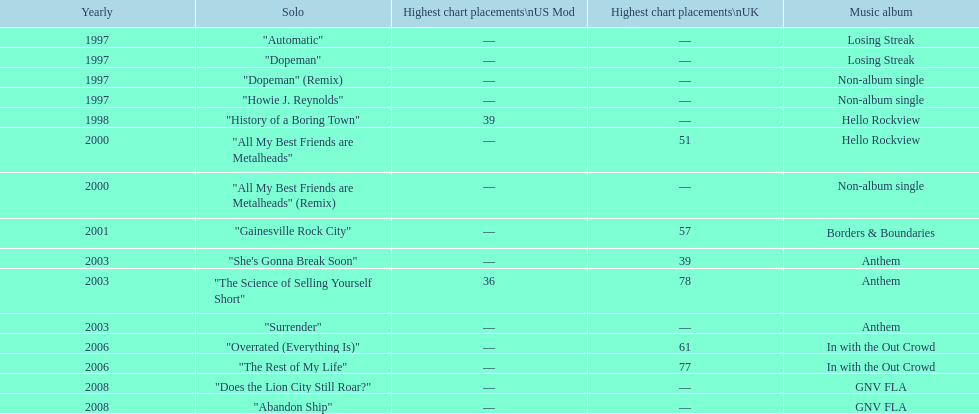Could you parse the entire table? {'header': ['Yearly', 'Solo', 'Highest chart placements\\nUS Mod', 'Highest chart placements\\nUK', 'Music album'], 'rows': [['1997', '"Automatic"', '—', '—', 'Losing Streak'], ['1997', '"Dopeman"', '—', '—', 'Losing Streak'], ['1997', '"Dopeman" (Remix)', '—', '—', 'Non-album single'], ['1997', '"Howie J. Reynolds"', '—', '—', 'Non-album single'], ['1998', '"History of a Boring Town"', '39', '—', 'Hello Rockview'], ['2000', '"All My Best Friends are Metalheads"', '—', '51', 'Hello Rockview'], ['2000', '"All My Best Friends are Metalheads" (Remix)', '—', '—', 'Non-album single'], ['2001', '"Gainesville Rock City"', '—', '57', 'Borders & Boundaries'], ['2003', '"She\'s Gonna Break Soon"', '—', '39', 'Anthem'], ['2003', '"The Science of Selling Yourself Short"', '36', '78', 'Anthem'], ['2003', '"Surrender"', '—', '—', 'Anthem'], ['2006', '"Overrated (Everything Is)"', '—', '61', 'In with the Out Crowd'], ['2006', '"The Rest of My Life"', '—', '77', 'In with the Out Crowd'], ['2008', '"Does the Lion City Still Roar?"', '—', '—', 'GNV FLA'], ['2008', '"Abandon Ship"', '—', '—', 'GNV FLA']]} Compare the chart positions between the us and the uk for the science of selling yourself short, where did it do better? US. 